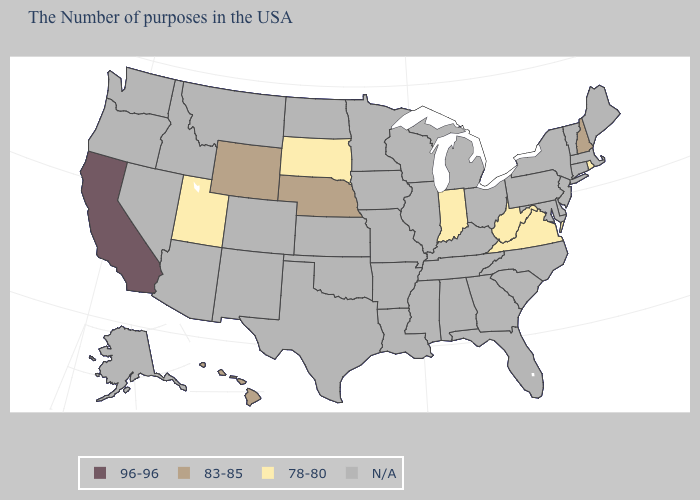What is the highest value in the USA?
Quick response, please. 96-96. What is the value of South Dakota?
Answer briefly. 78-80. What is the value of Alabama?
Be succinct. N/A. Which states have the lowest value in the Northeast?
Give a very brief answer. Rhode Island. Name the states that have a value in the range 78-80?
Keep it brief. Rhode Island, Virginia, West Virginia, Indiana, South Dakota, Utah. What is the value of California?
Be succinct. 96-96. What is the highest value in the Northeast ?
Write a very short answer. 83-85. What is the value of Montana?
Concise answer only. N/A. What is the value of Minnesota?
Quick response, please. N/A. Name the states that have a value in the range 83-85?
Write a very short answer. New Hampshire, Nebraska, Wyoming, Hawaii. Is the legend a continuous bar?
Short answer required. No. Does Nebraska have the highest value in the MidWest?
Write a very short answer. Yes. Name the states that have a value in the range 83-85?
Give a very brief answer. New Hampshire, Nebraska, Wyoming, Hawaii. What is the value of Hawaii?
Concise answer only. 83-85. 